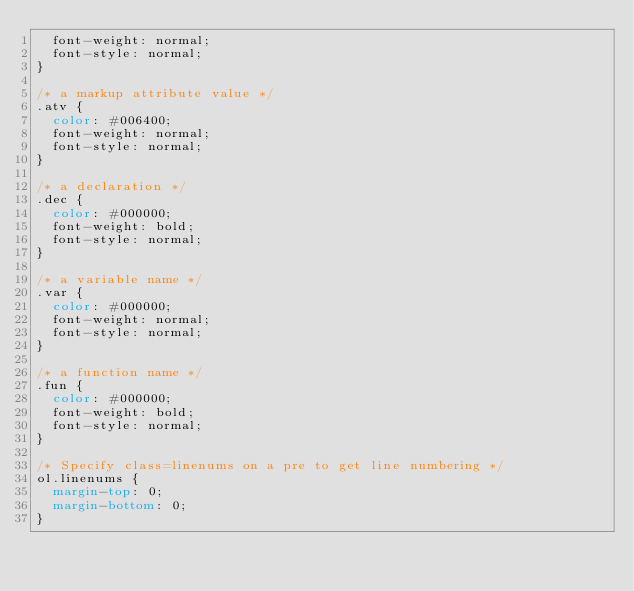<code> <loc_0><loc_0><loc_500><loc_500><_CSS_>	font-weight: normal;
	font-style: normal;
}

/* a markup attribute value */
.atv {
	color: #006400;
	font-weight: normal;
	font-style: normal;
}

/* a declaration */
.dec {
	color: #000000;
	font-weight: bold;
	font-style: normal;
}

/* a variable name */
.var {
	color: #000000;
	font-weight: normal;
	font-style: normal;
}

/* a function name */
.fun {
	color: #000000;
	font-weight: bold;
	font-style: normal;
}

/* Specify class=linenums on a pre to get line numbering */
ol.linenums {
	margin-top: 0;
	margin-bottom: 0;
}
</code> 